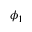<formula> <loc_0><loc_0><loc_500><loc_500>\phi _ { 1 }</formula> 